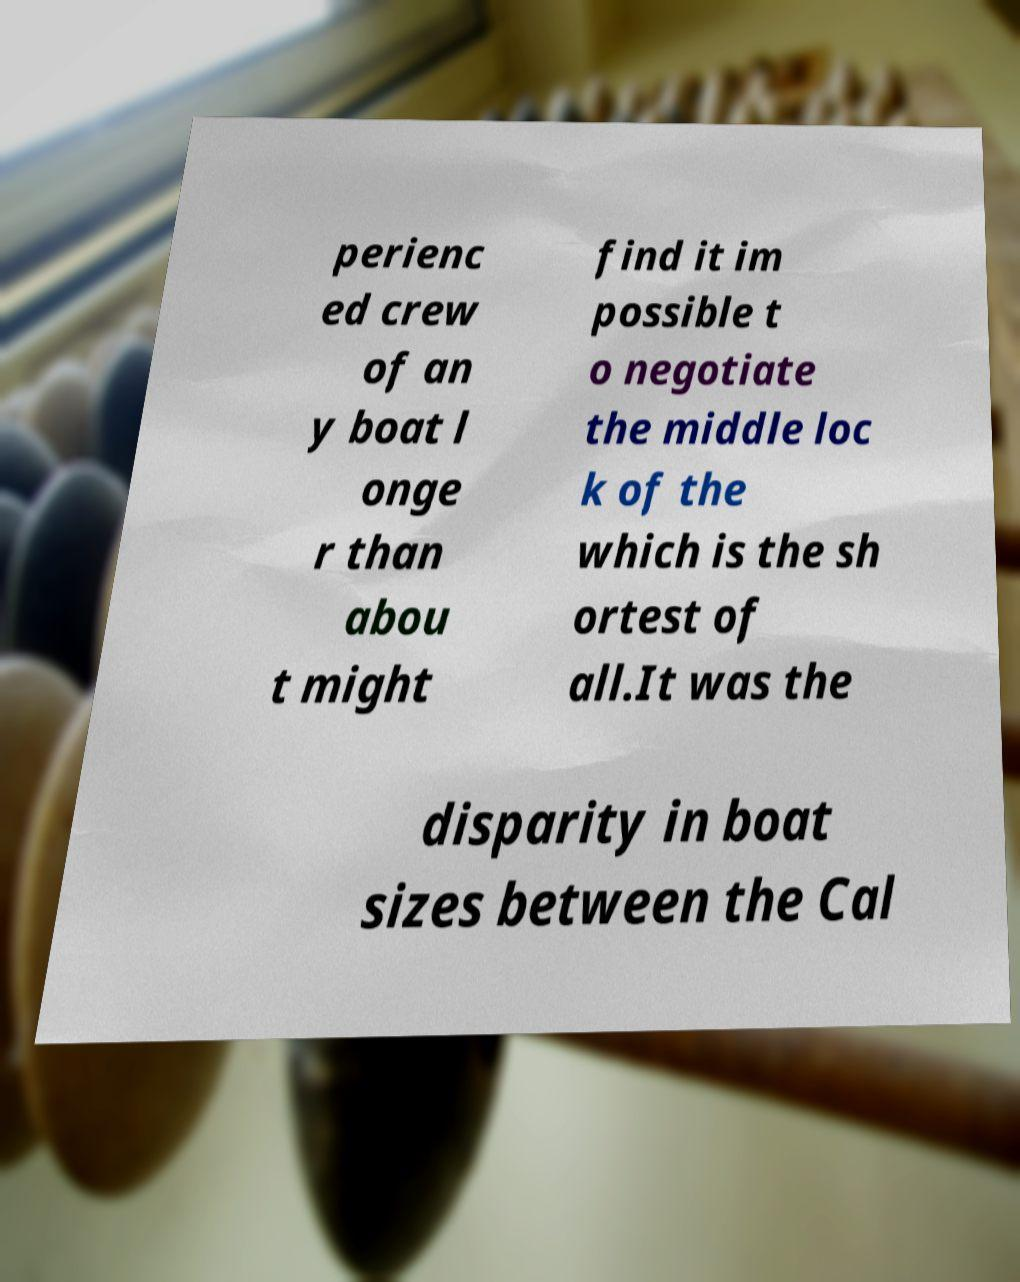For documentation purposes, I need the text within this image transcribed. Could you provide that? perienc ed crew of an y boat l onge r than abou t might find it im possible t o negotiate the middle loc k of the which is the sh ortest of all.It was the disparity in boat sizes between the Cal 